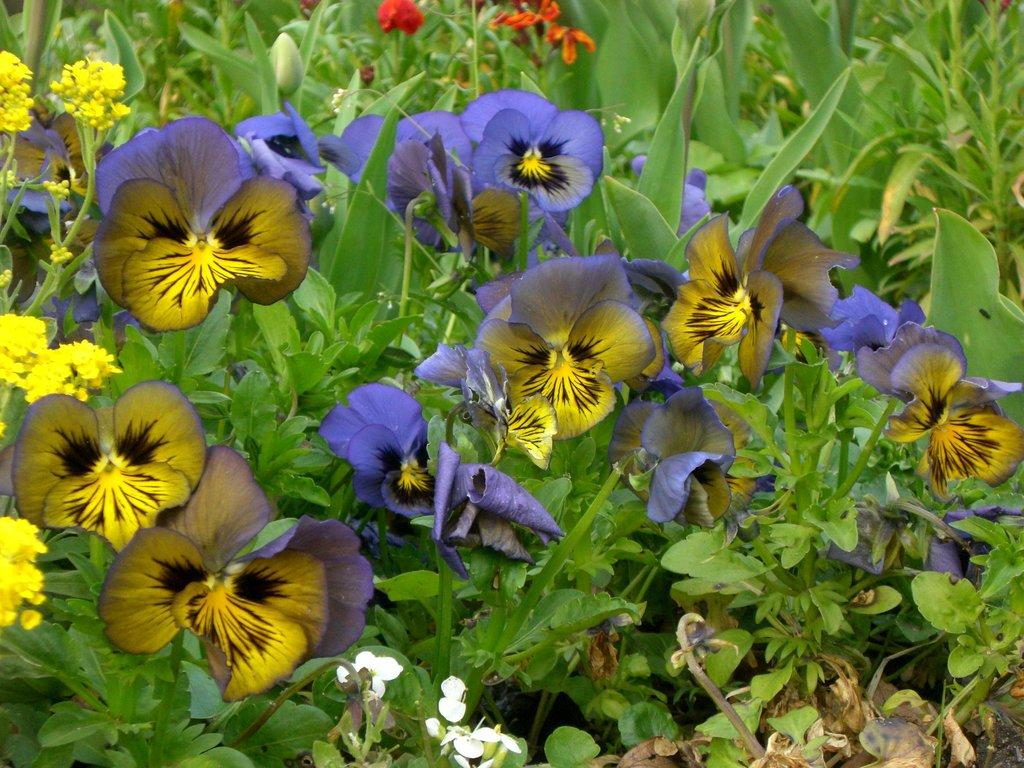What type of living organisms can be seen in the image? There are flowers and plants in the image. Can you describe the plants in the image? The image contains flowers, which are a type of plant. How many masks are hanging on the plants in the image? There are no masks present in the image; it only contains flowers and plants. 